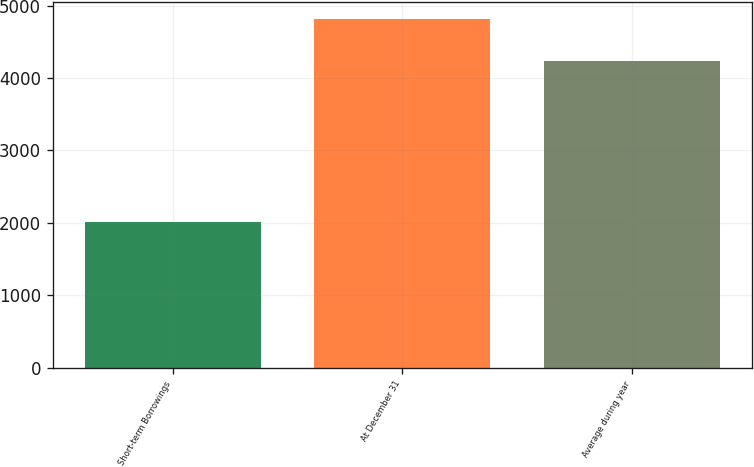<chart> <loc_0><loc_0><loc_500><loc_500><bar_chart><fcel>Short-term Borrowings<fcel>At December 31<fcel>Average during year<nl><fcel>2009<fcel>4814<fcel>4239<nl></chart> 